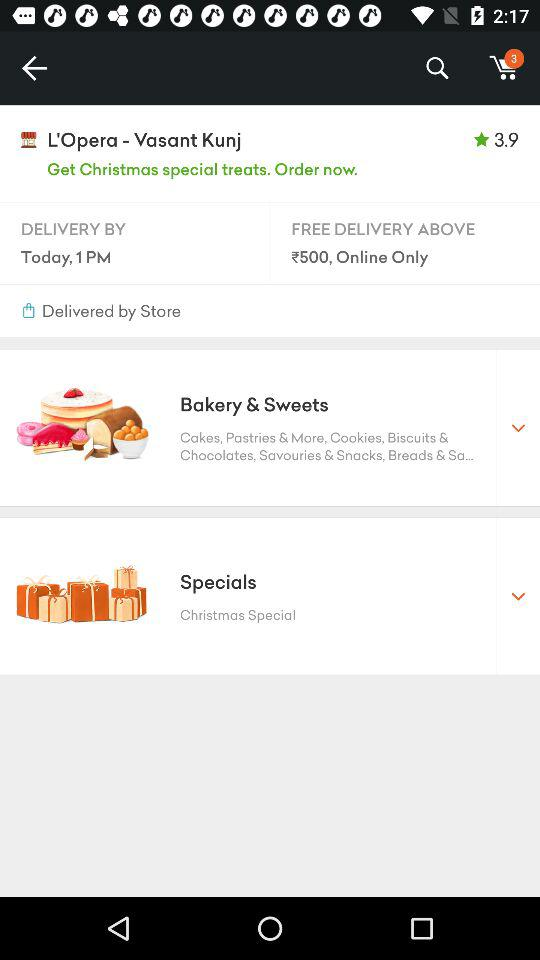What is the delivery time for today? The delivery time for today is 1 p.m. 